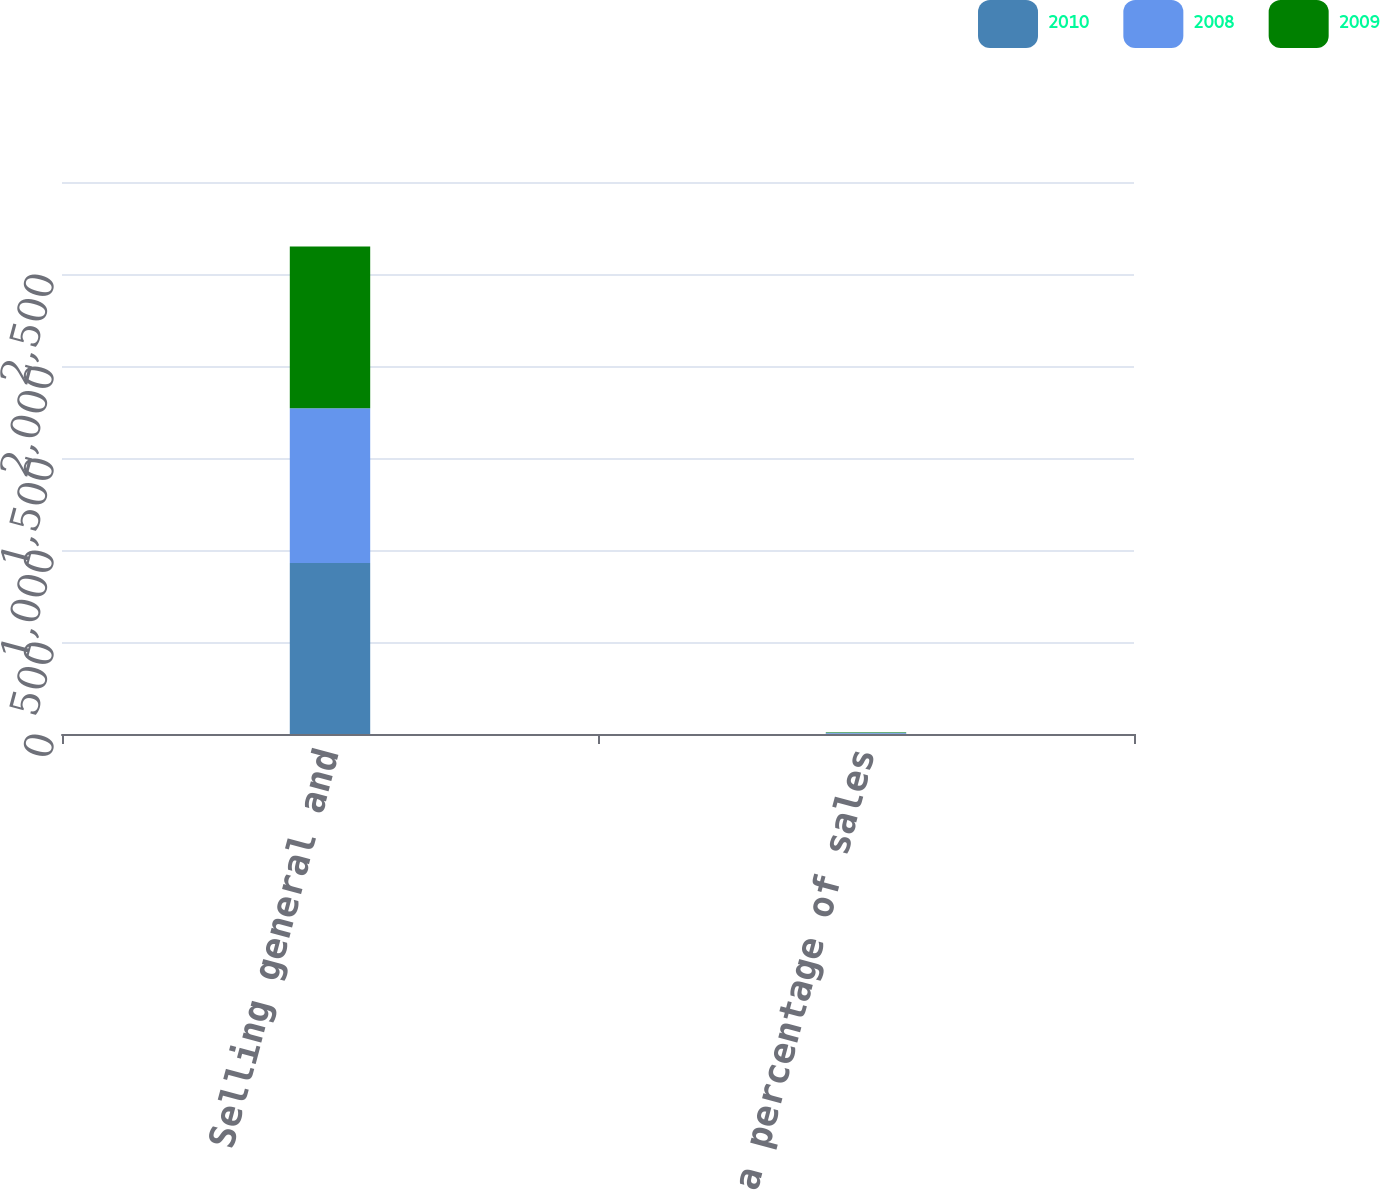Convert chart to OTSL. <chart><loc_0><loc_0><loc_500><loc_500><stacked_bar_chart><ecel><fcel>Selling general and<fcel>As a percentage of sales<nl><fcel>2010<fcel>929<fcel>3.3<nl><fcel>2008<fcel>841<fcel>3.1<nl><fcel>2009<fcel>879<fcel>3.3<nl></chart> 